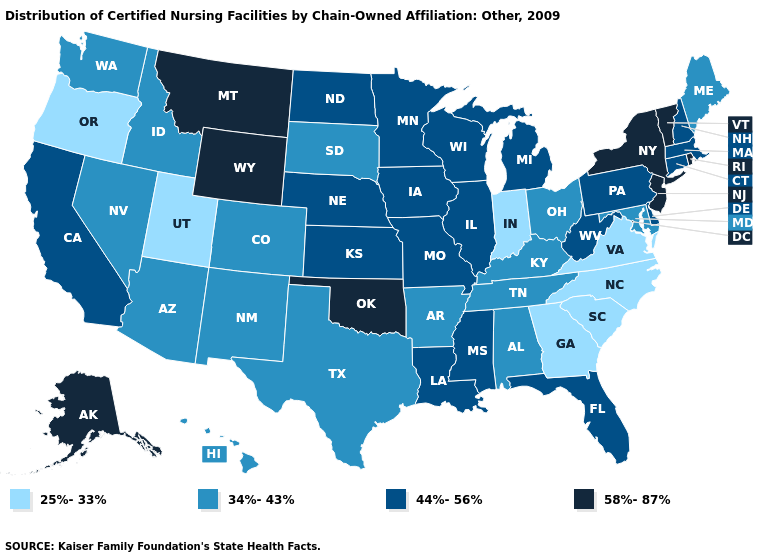Among the states that border West Virginia , does Maryland have the lowest value?
Quick response, please. No. Among the states that border Indiana , which have the highest value?
Keep it brief. Illinois, Michigan. Name the states that have a value in the range 58%-87%?
Answer briefly. Alaska, Montana, New Jersey, New York, Oklahoma, Rhode Island, Vermont, Wyoming. What is the value of Hawaii?
Short answer required. 34%-43%. Name the states that have a value in the range 44%-56%?
Concise answer only. California, Connecticut, Delaware, Florida, Illinois, Iowa, Kansas, Louisiana, Massachusetts, Michigan, Minnesota, Mississippi, Missouri, Nebraska, New Hampshire, North Dakota, Pennsylvania, West Virginia, Wisconsin. What is the value of Rhode Island?
Be succinct. 58%-87%. What is the value of New York?
Write a very short answer. 58%-87%. Does New Jersey have the highest value in the Northeast?
Give a very brief answer. Yes. Which states have the lowest value in the USA?
Be succinct. Georgia, Indiana, North Carolina, Oregon, South Carolina, Utah, Virginia. Name the states that have a value in the range 44%-56%?
Be succinct. California, Connecticut, Delaware, Florida, Illinois, Iowa, Kansas, Louisiana, Massachusetts, Michigan, Minnesota, Mississippi, Missouri, Nebraska, New Hampshire, North Dakota, Pennsylvania, West Virginia, Wisconsin. Is the legend a continuous bar?
Short answer required. No. What is the highest value in the USA?
Quick response, please. 58%-87%. Name the states that have a value in the range 34%-43%?
Short answer required. Alabama, Arizona, Arkansas, Colorado, Hawaii, Idaho, Kentucky, Maine, Maryland, Nevada, New Mexico, Ohio, South Dakota, Tennessee, Texas, Washington. Does Maryland have the lowest value in the USA?
Answer briefly. No. Does Oklahoma have the highest value in the South?
Answer briefly. Yes. 